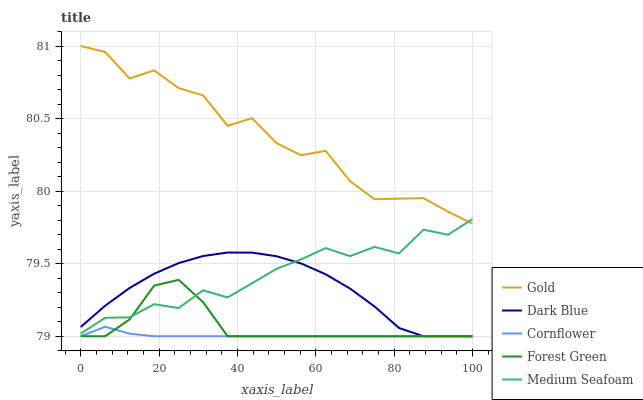Does Cornflower have the minimum area under the curve?
Answer yes or no. Yes. Does Gold have the maximum area under the curve?
Answer yes or no. Yes. Does Forest Green have the minimum area under the curve?
Answer yes or no. No. Does Forest Green have the maximum area under the curve?
Answer yes or no. No. Is Cornflower the smoothest?
Answer yes or no. Yes. Is Gold the roughest?
Answer yes or no. Yes. Is Forest Green the smoothest?
Answer yes or no. No. Is Forest Green the roughest?
Answer yes or no. No. Does Dark Blue have the lowest value?
Answer yes or no. Yes. Does Medium Seafoam have the lowest value?
Answer yes or no. No. Does Gold have the highest value?
Answer yes or no. Yes. Does Forest Green have the highest value?
Answer yes or no. No. Is Cornflower less than Gold?
Answer yes or no. Yes. Is Gold greater than Forest Green?
Answer yes or no. Yes. Does Forest Green intersect Dark Blue?
Answer yes or no. Yes. Is Forest Green less than Dark Blue?
Answer yes or no. No. Is Forest Green greater than Dark Blue?
Answer yes or no. No. Does Cornflower intersect Gold?
Answer yes or no. No. 